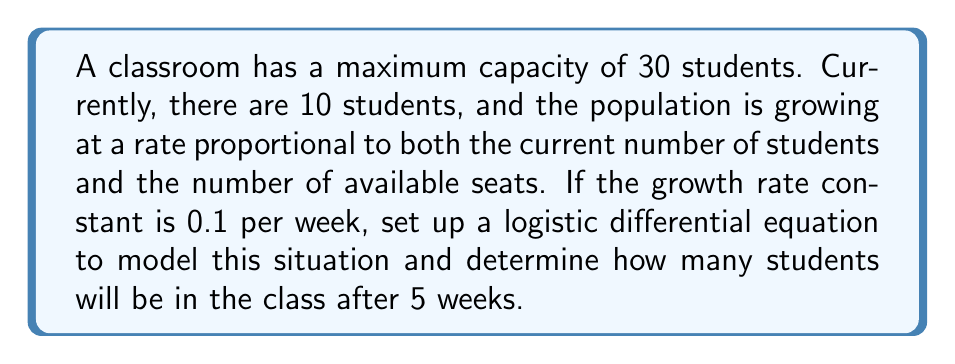Show me your answer to this math problem. Let's approach this step-by-step:

1) First, we need to set up the logistic differential equation. The general form is:

   $$\frac{dP}{dt} = rP(1 - \frac{P}{K})$$

   Where:
   - $P$ is the population (number of students)
   - $t$ is time (in weeks)
   - $r$ is the growth rate constant
   - $K$ is the carrying capacity (maximum number of students)

2) We're given:
   - $K = 30$ (maximum capacity)
   - $r = 0.1$ (growth rate constant per week)
   - $P(0) = 10$ (initial number of students)

3) Substituting these values, our specific equation is:

   $$\frac{dP}{dt} = 0.1P(1 - \frac{P}{30})$$

4) To solve this, we need to use the logistic growth formula:

   $$P(t) = \frac{K}{1 + (\frac{K}{P_0} - 1)e^{-rt}}$$

   Where $P_0$ is the initial population.

5) Substituting our values:

   $$P(t) = \frac{30}{1 + (\frac{30}{10} - 1)e^{-0.1t}}$$

6) Simplify:

   $$P(t) = \frac{30}{1 + 2e^{-0.1t}}$$

7) Now, we want to find $P(5)$, so let's substitute $t = 5$:

   $$P(5) = \frac{30}{1 + 2e^{-0.5}}$$

8) Calculate:
   $$P(5) = \frac{30}{1 + 2(0.6065)} \approx 18.55$$

9) Since we can't have a fractional number of students, we round to the nearest whole number.
Answer: After 5 weeks, there will be approximately 19 students in the class. 